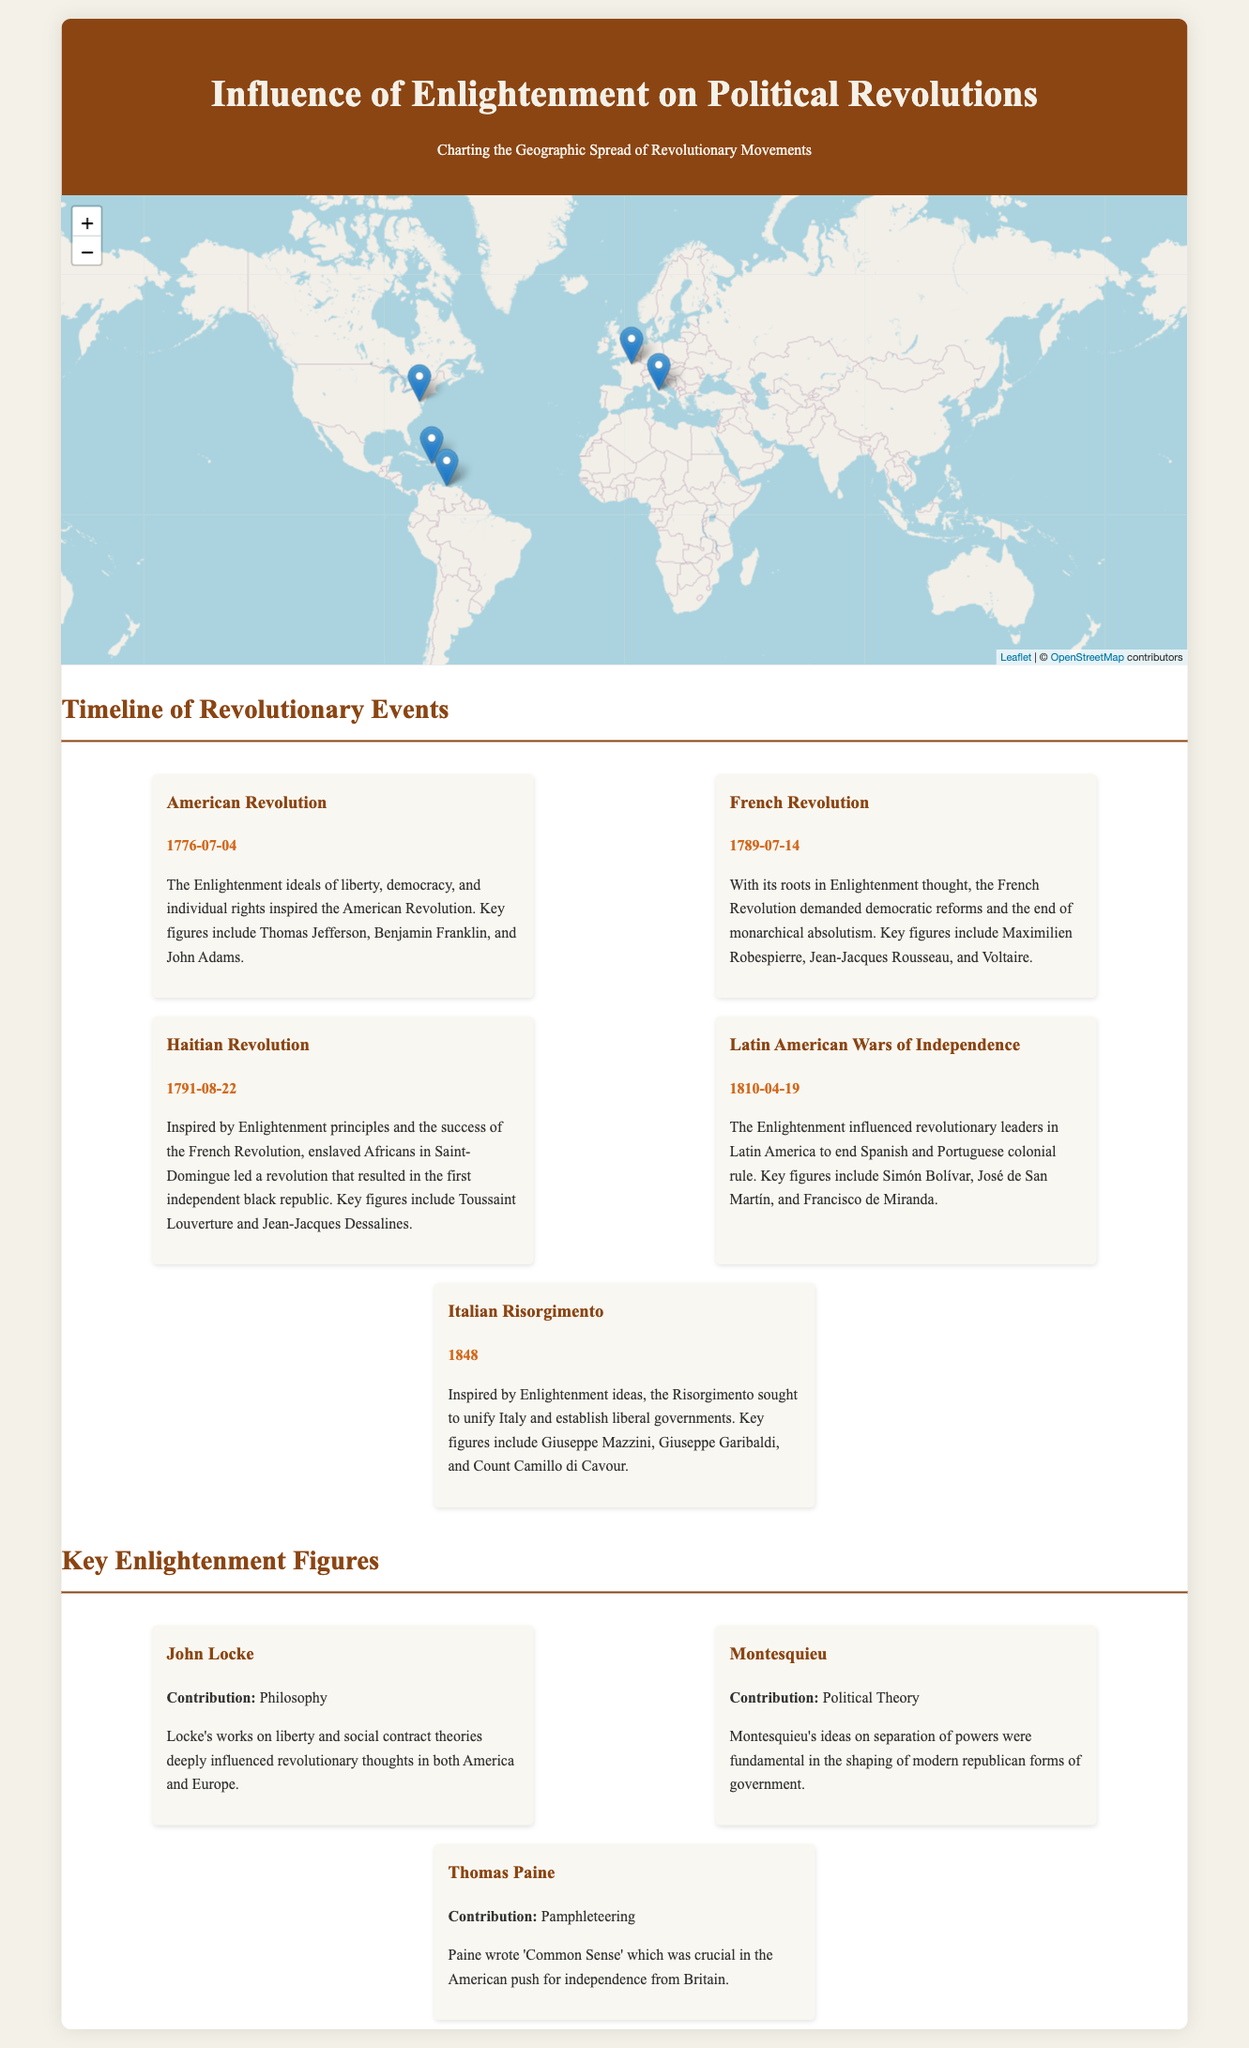What date did the American Revolution begin? The document specifies that the American Revolution began on July 4, 1776.
Answer: July 4, 1776 Who was a key figure in the French Revolution? The document lists Maximilien Robespierre, Jean-Jacques Rousseau, and Voltaire as key figures in the French Revolution.
Answer: Maximilien Robespierre What event is indicated by the date August 22, 1791? The document associates this date with the Haitian Revolution, which started on that day.
Answer: Haitian Revolution Which political theory did Montesquieu contribute to? Montesquieu's contribution is noted as political theory, specifically regarding the separation of powers.
Answer: Separation of powers How many identified revolutionary events are depicted in the infographic? The document lists a total of five revolutionary events.
Answer: Five What geographic location corresponds with the Latin American Wars of Independence? The coordinates provided in the document for this event are approximately [10.4806, -66.9036].
Answer: [10.4806, -66.9036] How did Enlightenment ideas impact the Italian Risorgimento? The document states that the Risorgimento sought to unify Italy and establish liberal governments, influenced by Enlightenment ideas.
Answer: Unify Italy and establish liberal governments Which revolution is associated with the year 1810? The document indicates that the Latin American Wars of Independence began in that year.
Answer: Latin American Wars of Independence Who penned 'Common Sense'? The document identifies Thomas Paine as the author of 'Common Sense.'
Answer: Thomas Paine 